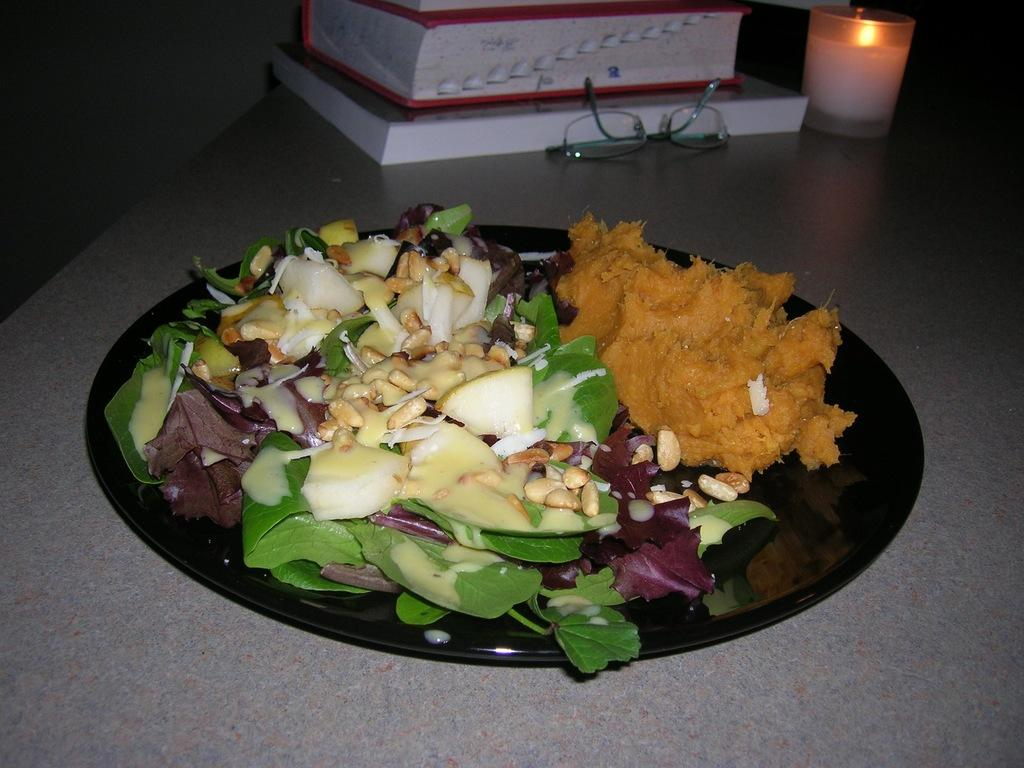What is the color of the plate on which the food items are placed? The plate is black in color. What other items can be seen on the surface besides the food items? There are books, spectacles, and a candle on the surface. What type of iron can be seen in the image? There is no iron present in the image. How does the sleet affect the food items on the plate? There is no sleet present in the image, so it cannot affect the food items. 